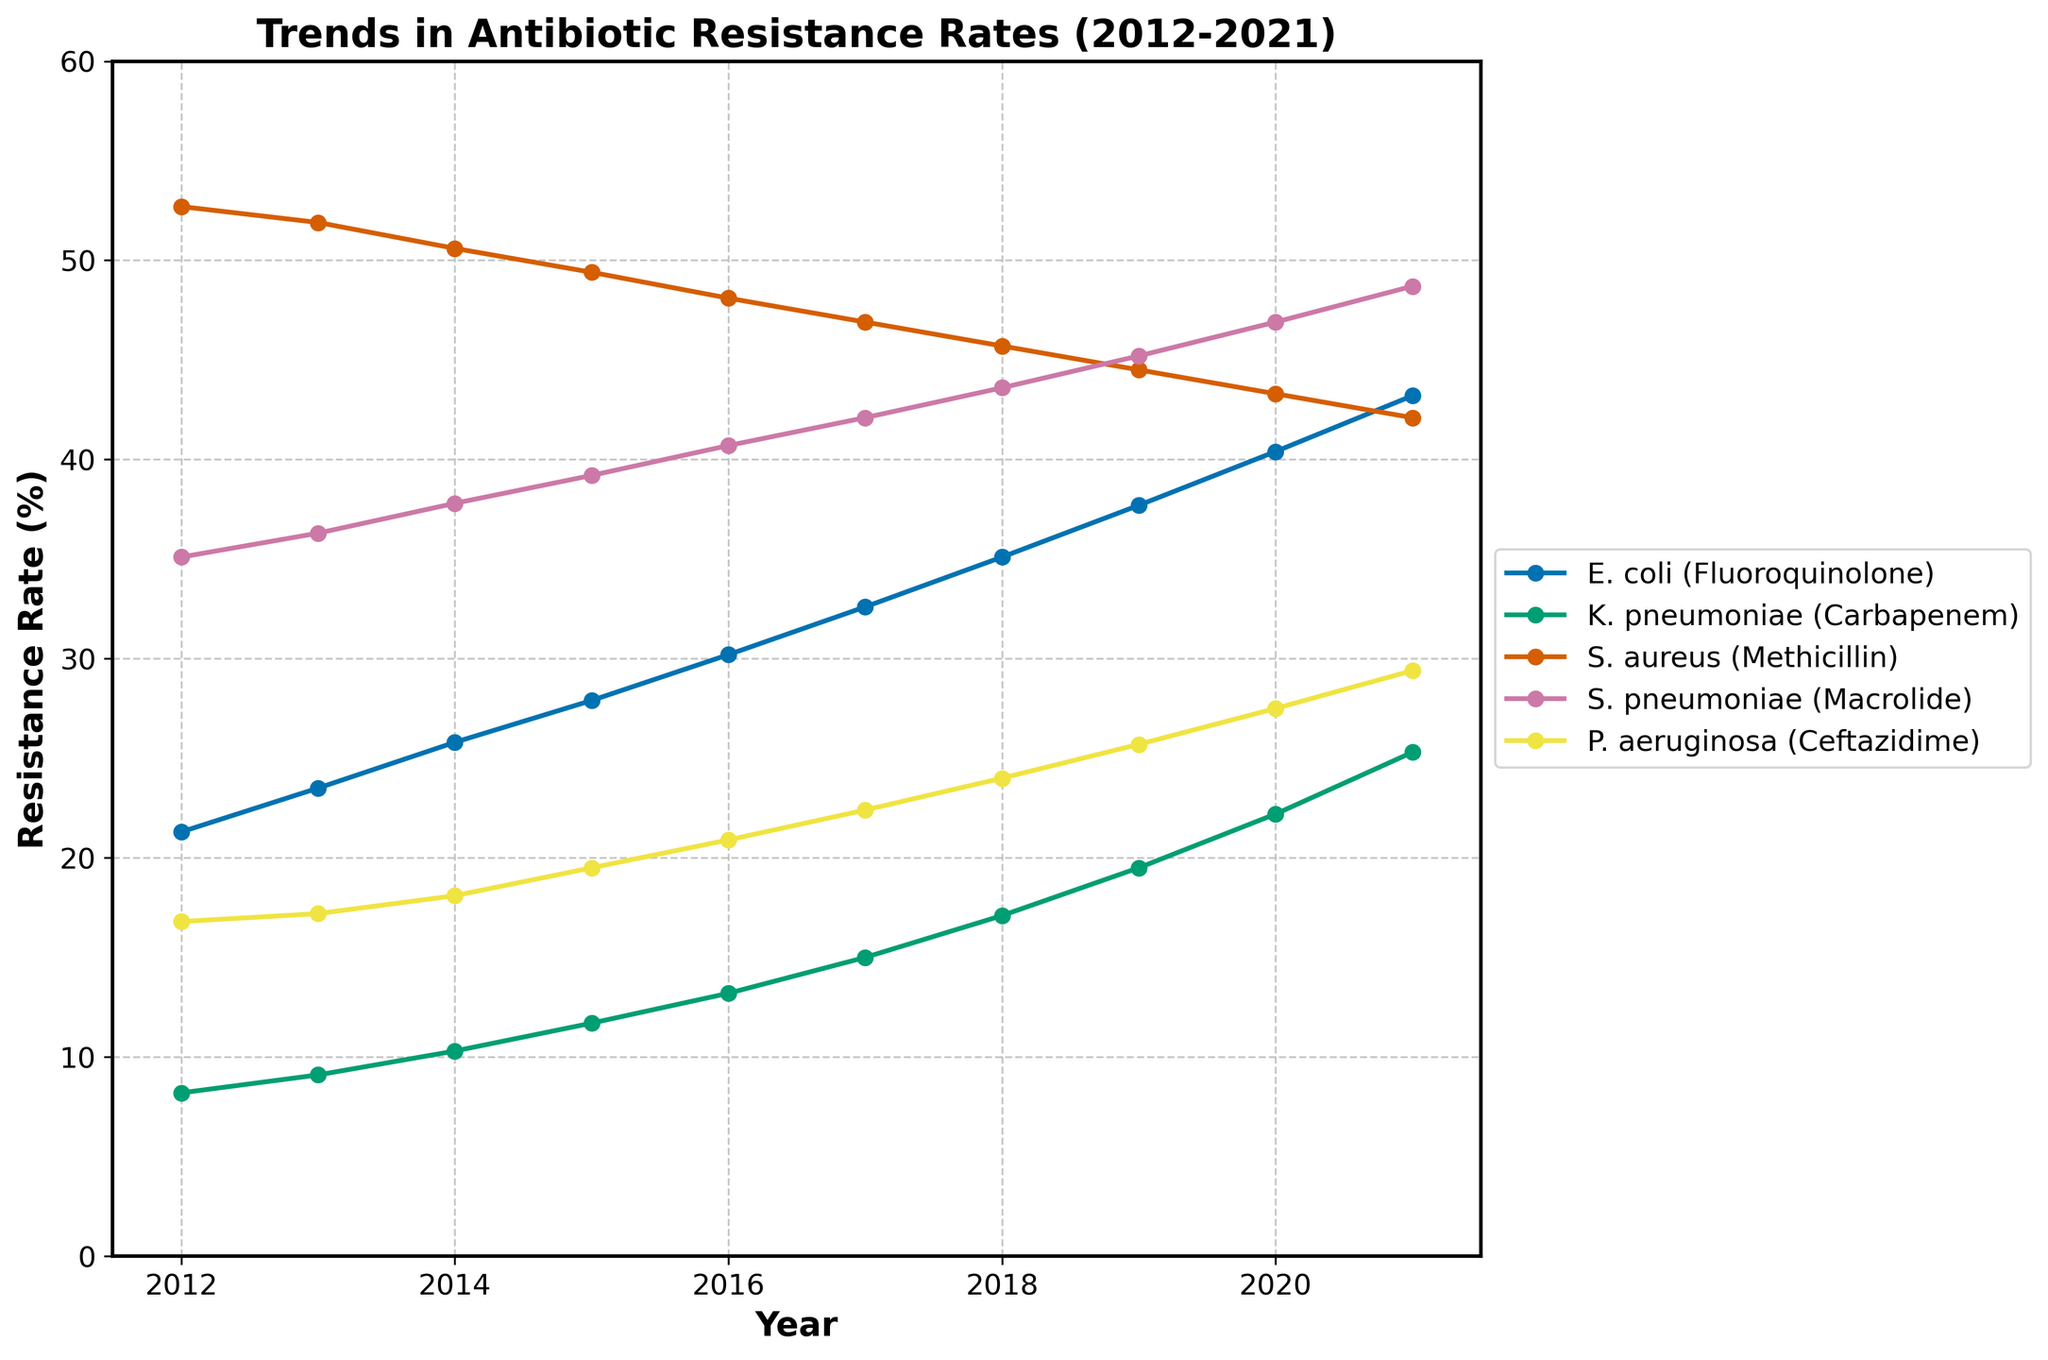Which bacterial infection showed the highest antibiotic resistance rate in 2021? Look at the endpoints of all lines for the year 2021 and identify the highest point on the vertical axis.
Answer: S. aureus (Methicillin) Between 2012 and 2021, how many percentage points did the resistance rate for E. coli (Fluoroquinolone) increase? Find the resistance rates for E. coli (Fluoroquinolone) in 2012 and 2021, then subtract the 2012 value from the 2021 value (43.2 - 21.3).
Answer: 21.9 Which bacterial infection had the steepest increase in antibiotic resistance rate over the decade? Compare the slopes of all lines, which represent the rate of change. The line that rises the fastest has the steepest increase.
Answer: E. coli (Fluoroquinolone) In what year did the antibiotic resistance rate for K. pneumoniae (Carbapenem) surpass 20%? Identify the point at which the K. pneumoniae (Carbapenem) line first crosses the 20% mark on the vertical axis.
Answer: 2020 What is the average antibiotic resistance rate of P. aeruginosa (Ceftazidime) from 2012 to 2021? Sum the resistance rates of P. aeruginosa (Ceftazidime) from 2012 to 2021, then divide by the number of years (16.8 + 17.2 + 18.1 + 19.5 + 20.9 + 22.4 + 24.0 + 25.7 + 27.5 + 29.4) / 10.
Answer: 22.15 Which bacterial infection had the least variability in its resistance rate over the decade? Observe the lines and see which one has the least fluctuation and the most stable slope.
Answer: S. aureus (Methicillin) By how many percentage points did the resistance rate for S. pneumoniae (Macrolide) increase from 2015 to 2021? Find the resistance rates for S. pneumoniae (Macrolide) in 2015 and 2021, then subtract the 2015 value from the 2021 value (48.7 - 39.2).
Answer: 9.5 Which year did the antibiotic resistance rate of E. coli (Fluoroquinolone) exceed that of S. aureus (Methicillin)? Compare the rates of E. coli (Fluoroquinolone) and S. aureus (Methicillin) for each year and identify the first year where E. coli's rate is higher.
Answer: 2020 How does the resistance trend of S. pneumoniae (Macrolide) compare to that of P. aeruginosa (Ceftazidime)? Look at the slopes of the lines for S. pneumoniae (Macrolide) and P. aeruginosa (Ceftazidime). Both show an increasing trend, but compare their slopes to see which is steeper.
Answer: Both increasing; S. pneumoniae is gradual, P. aeruginosa is slightly steeper Which bacterial infection had a resistance rate close to 50% in 2012, and how did this rate change by 2021? Identify the bacterial infection with a resistance rate near 50% in 2012, then find its rate in 2021 to observe the change.
Answer: S. aureus (Methicillin); decreased to 42.1% 